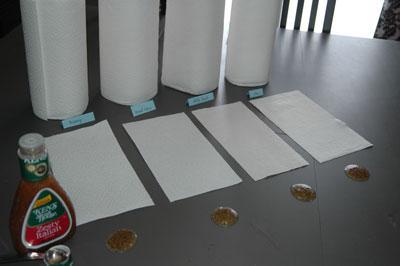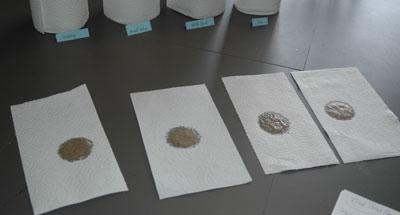The first image is the image on the left, the second image is the image on the right. Considering the images on both sides, is "An image shows one towel row mounted horizontally, with a sheet hanging toward the left." valid? Answer yes or no. No. The first image is the image on the left, the second image is the image on the right. Assess this claim about the two images: "In one image, a roll of paper towels is attached to a chrome hanging towel holder, while a second image shows a roll of paper towels on an upright towel holder.". Correct or not? Answer yes or no. No. 